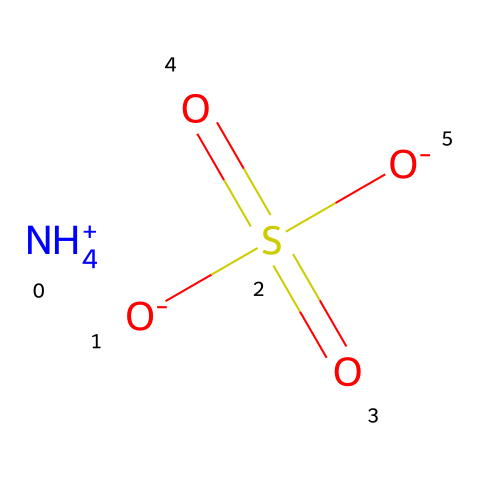What is the name of this chemical? The SMILES representation corresponds to ammonium bisulfate or ammonium hydrogen sulfate, which contains both ammonium (NH4+) and bisulfate (HSO4-) ions.
Answer: ammonium bisulfate How many oxygen atoms are in this structure? The bisulfate ion has four oxygen atoms connected to the sulfur atom, as indicated by the structure, which is confirmed by the two [O-] and two [O] connected to sulfur.
Answer: four What is the oxidation state of sulfur in this compound? In the bisulfate ion, sulfur is bonded to four oxygen atoms, with a total of -8 from the oxygens and +6 from the bond, giving it an oxidation state of +6.
Answer: +6 How many sulfur-containing functional groups are present? The compound contains one bisulfate functional group, which is characterized by the sulfur atom bonded to oxygen atoms, thus it has one sulfur-containing group.
Answer: one Which ion in this compound has a positive charge? The compound contains the ammonium ion (NH4+), which is positively charged as indicated by the “[NH4+]” notation in the SMILES representation.
Answer: ammonium Is this compound acidic or basic? The presence of the bisulfate ion, which can donate protons, indicates that this compound is acidic in nature, based on the behavior of its components in solution.
Answer: acidic 